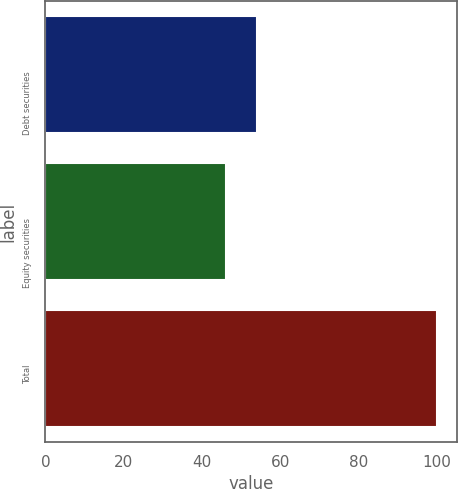<chart> <loc_0><loc_0><loc_500><loc_500><bar_chart><fcel>Debt securities<fcel>Equity securities<fcel>Total<nl><fcel>54<fcel>46<fcel>100<nl></chart> 